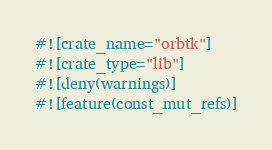Convert code to text. <code><loc_0><loc_0><loc_500><loc_500><_Rust_>#![crate_name="orbtk"]
#![crate_type="lib"]
#![deny(warnings)]
#![feature(const_mut_refs)]
</code> 